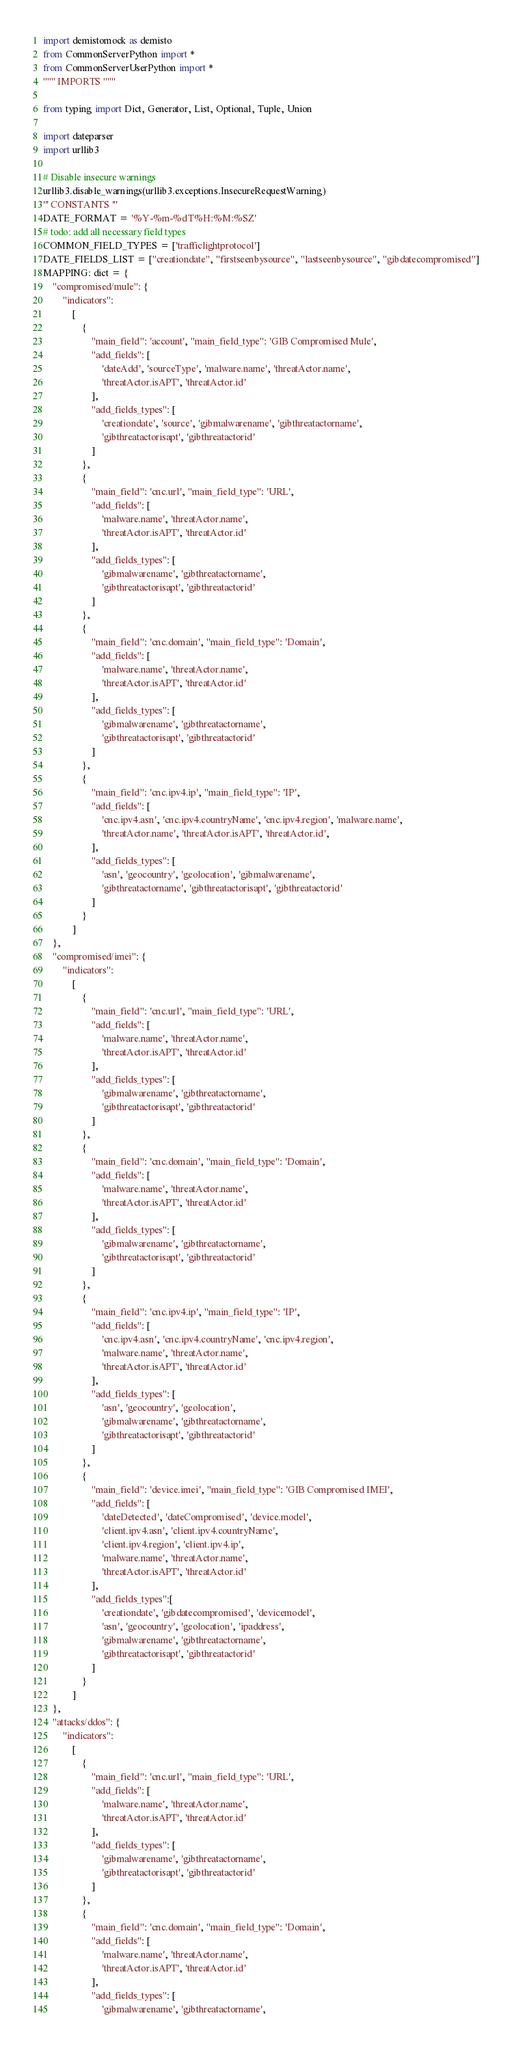<code> <loc_0><loc_0><loc_500><loc_500><_Python_>import demistomock as demisto
from CommonServerPython import *
from CommonServerUserPython import *
""" IMPORTS """

from typing import Dict, Generator, List, Optional, Tuple, Union

import dateparser
import urllib3

# Disable insecure warnings
urllib3.disable_warnings(urllib3.exceptions.InsecureRequestWarning)
''' CONSTANTS '''
DATE_FORMAT = '%Y-%m-%dT%H:%M:%SZ'
# todo: add all necessary field types
COMMON_FIELD_TYPES = ['trafficlightprotocol']
DATE_FIELDS_LIST = ["creationdate", "firstseenbysource", "lastseenbysource", "gibdatecompromised"]
MAPPING: dict = {
    "compromised/mule": {
        "indicators":
            [
                {
                    "main_field": 'account', "main_field_type": 'GIB Compromised Mule',
                    "add_fields": [
                        'dateAdd', 'sourceType', 'malware.name', 'threatActor.name',
                        'threatActor.isAPT', 'threatActor.id'
                    ],
                    "add_fields_types": [
                        'creationdate', 'source', 'gibmalwarename', 'gibthreatactorname',
                        'gibthreatactorisapt', 'gibthreatactorid'
                    ]
                },
                {
                    "main_field": 'cnc.url', "main_field_type": 'URL',
                    "add_fields": [
                        'malware.name', 'threatActor.name',
                        'threatActor.isAPT', 'threatActor.id'
                    ],
                    "add_fields_types": [
                        'gibmalwarename', 'gibthreatactorname',
                        'gibthreatactorisapt', 'gibthreatactorid'
                    ]
                },
                {
                    "main_field": 'cnc.domain', "main_field_type": 'Domain',
                    "add_fields": [
                        'malware.name', 'threatActor.name',
                        'threatActor.isAPT', 'threatActor.id'
                    ],
                    "add_fields_types": [
                        'gibmalwarename', 'gibthreatactorname',
                        'gibthreatactorisapt', 'gibthreatactorid'
                    ]
                },
                {
                    "main_field": 'cnc.ipv4.ip', "main_field_type": 'IP',
                    "add_fields": [
                        'cnc.ipv4.asn', 'cnc.ipv4.countryName', 'cnc.ipv4.region', 'malware.name',
                        'threatActor.name', 'threatActor.isAPT', 'threatActor.id',
                    ],
                    "add_fields_types": [
                        'asn', 'geocountry', 'geolocation', 'gibmalwarename',
                        'gibthreatactorname', 'gibthreatactorisapt', 'gibthreatactorid'
                    ]
                }
            ]
    },
    "compromised/imei": {
        "indicators":
            [
                {
                    "main_field": 'cnc.url', "main_field_type": 'URL',
                    "add_fields": [
                        'malware.name', 'threatActor.name',
                        'threatActor.isAPT', 'threatActor.id'
                    ],
                    "add_fields_types": [
                        'gibmalwarename', 'gibthreatactorname',
                        'gibthreatactorisapt', 'gibthreatactorid'
                    ]
                },
                {
                    "main_field": 'cnc.domain', "main_field_type": 'Domain',
                    "add_fields": [
                        'malware.name', 'threatActor.name',
                        'threatActor.isAPT', 'threatActor.id'
                    ],
                    "add_fields_types": [
                        'gibmalwarename', 'gibthreatactorname',
                        'gibthreatactorisapt', 'gibthreatactorid'
                    ]
                },
                {
                    "main_field": 'cnc.ipv4.ip', "main_field_type": 'IP',
                    "add_fields": [
                        'cnc.ipv4.asn', 'cnc.ipv4.countryName', 'cnc.ipv4.region',
                        'malware.name', 'threatActor.name',
                        'threatActor.isAPT', 'threatActor.id'
                    ],
                    "add_fields_types": [
                        'asn', 'geocountry', 'geolocation',
                        'gibmalwarename', 'gibthreatactorname',
                        'gibthreatactorisapt', 'gibthreatactorid'
                    ]
                },
                {
                    "main_field": 'device.imei', "main_field_type": 'GIB Compromised IMEI',
                    "add_fields": [
                        'dateDetected', 'dateCompromised', 'device.model',
                        'client.ipv4.asn', 'client.ipv4.countryName',
                        'client.ipv4.region', 'client.ipv4.ip',
                        'malware.name', 'threatActor.name',
                        'threatActor.isAPT', 'threatActor.id'
                    ],
                    "add_fields_types":[
                        'creationdate', 'gibdatecompromised', 'devicemodel',
                        'asn', 'geocountry', 'geolocation', 'ipaddress',
                        'gibmalwarename', 'gibthreatactorname',
                        'gibthreatactorisapt', 'gibthreatactorid'
                    ]
                }
            ]
    },
    "attacks/ddos": {
        "indicators":
            [
                {
                    "main_field": 'cnc.url', "main_field_type": 'URL',
                    "add_fields": [
                        'malware.name', 'threatActor.name',
                        'threatActor.isAPT', 'threatActor.id'
                    ],
                    "add_fields_types": [
                        'gibmalwarename', 'gibthreatactorname',
                        'gibthreatactorisapt', 'gibthreatactorid'
                    ]
                },
                {
                    "main_field": 'cnc.domain', "main_field_type": 'Domain',
                    "add_fields": [
                        'malware.name', 'threatActor.name',
                        'threatActor.isAPT', 'threatActor.id'
                    ],
                    "add_fields_types": [
                        'gibmalwarename', 'gibthreatactorname',</code> 